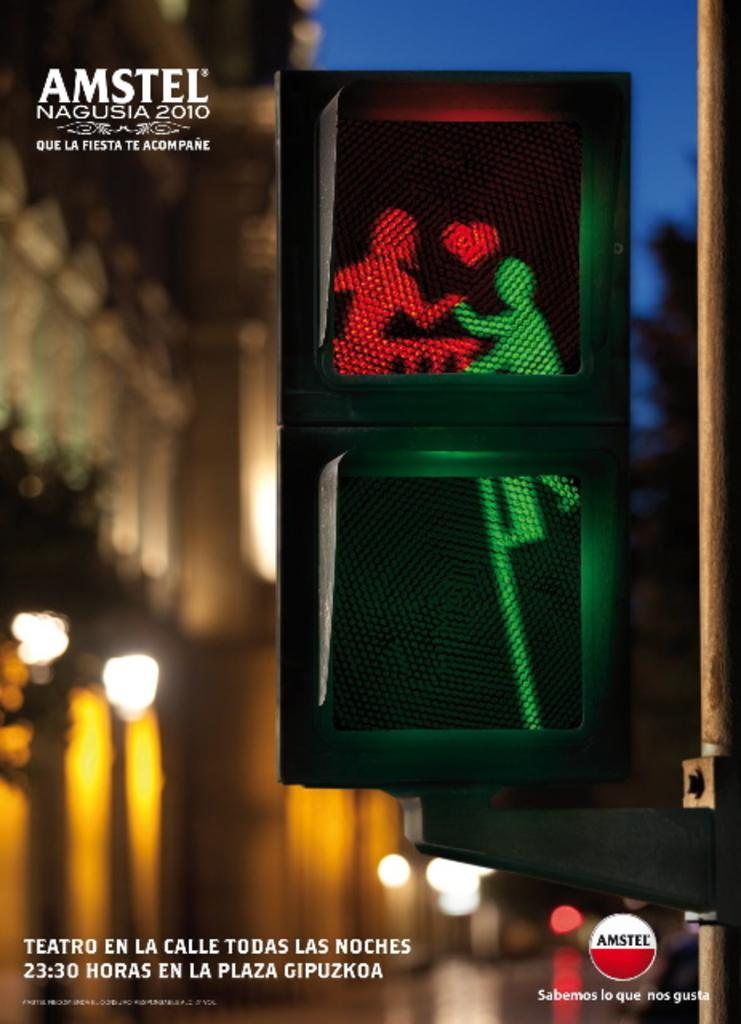<image>
Create a compact narrative representing the image presented. an amstel as with a guy and girl in live on it 